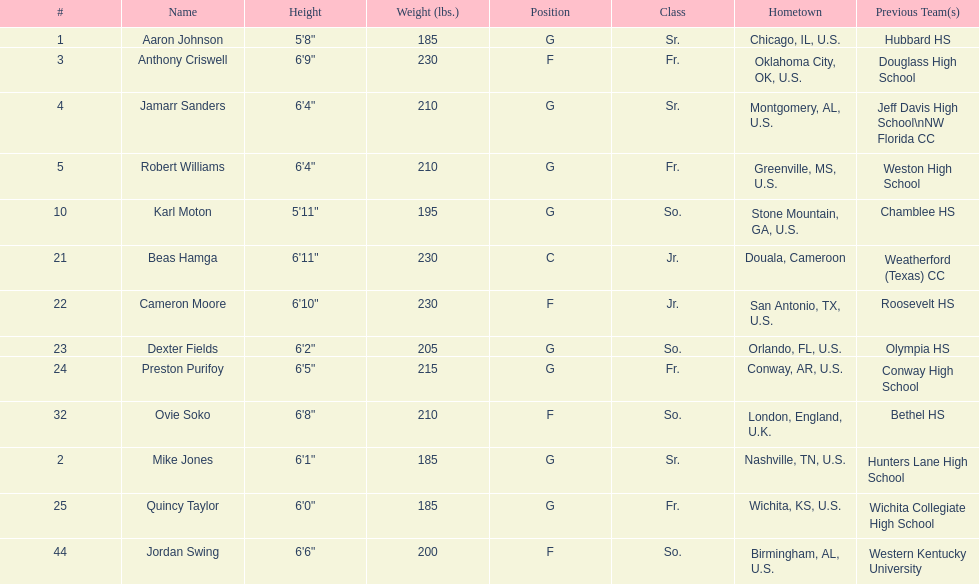How many forwards does the team have in total? 4. 